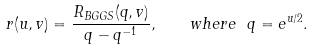<formula> <loc_0><loc_0><loc_500><loc_500>r ( u , v ) = \frac { R _ { B G G S } ( q , v ) } { q - q ^ { - 1 } } , \quad w h e r e \ q = e ^ { u / 2 } .</formula> 